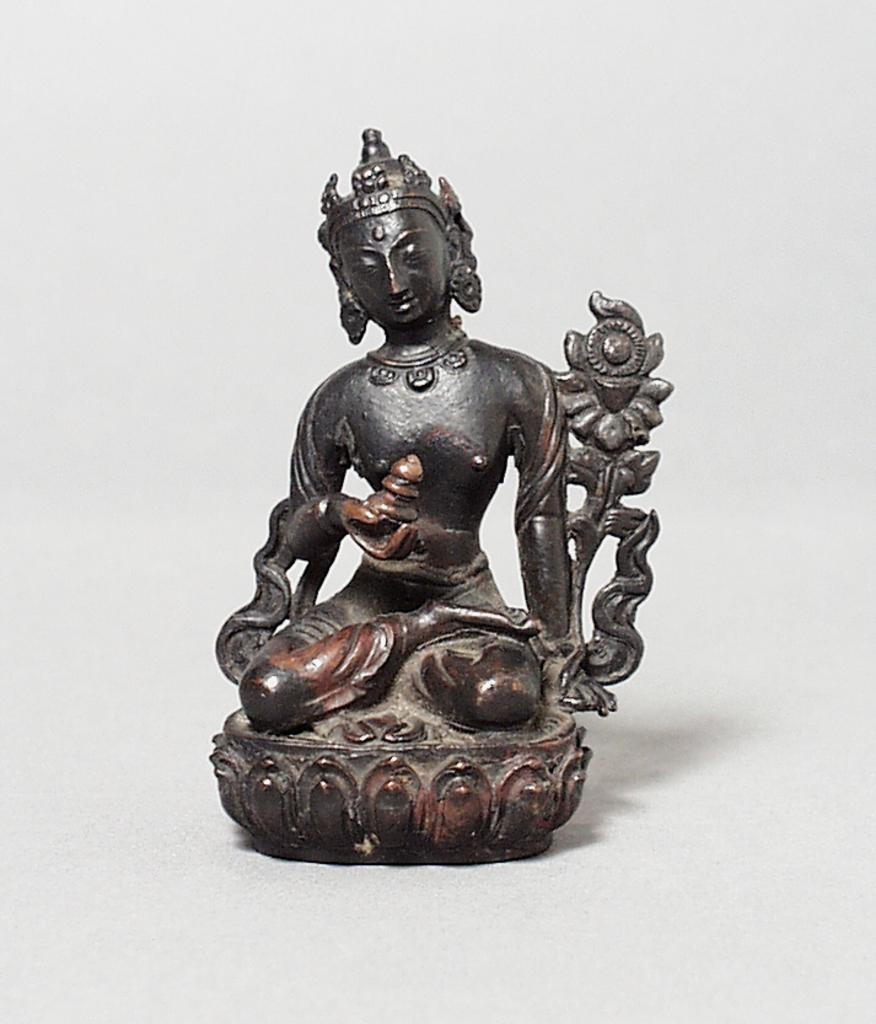What is the main subject in the center of the image? There is a sculpture in the center of the image. How does the crowd react to the voice coming from the sculpture in the image? There is no crowd or voice present in the image; it only features a sculpture. 